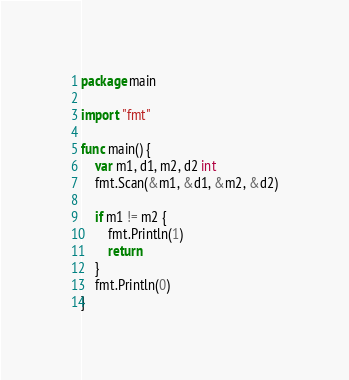<code> <loc_0><loc_0><loc_500><loc_500><_Go_>package main

import "fmt"

func main() {
	var m1, d1, m2, d2 int
	fmt.Scan(&m1, &d1, &m2, &d2)

	if m1 != m2 {
		fmt.Println(1)
		return
	}
	fmt.Println(0)
}
</code> 